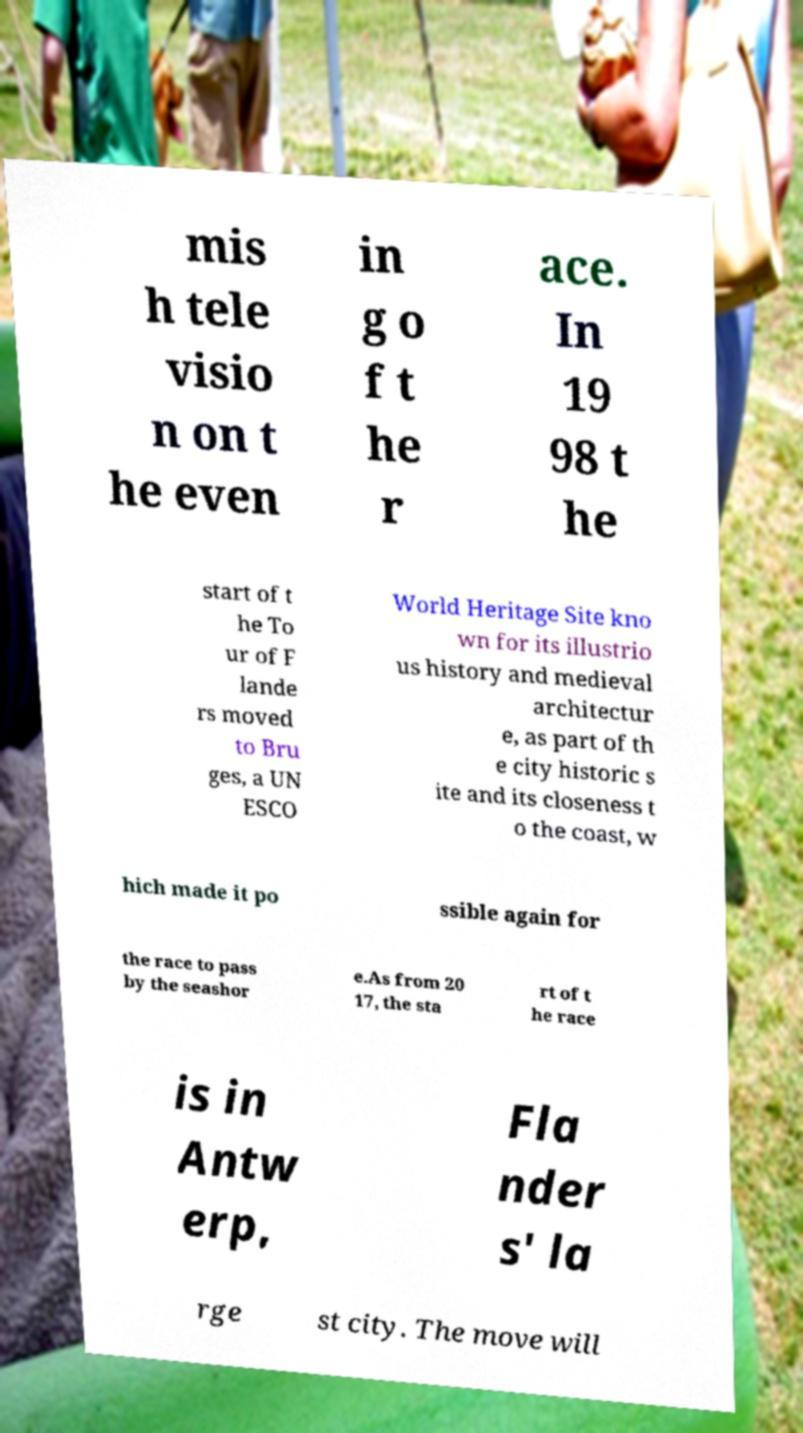Could you extract and type out the text from this image? mis h tele visio n on t he even in g o f t he r ace. In 19 98 t he start of t he To ur of F lande rs moved to Bru ges, a UN ESCO World Heritage Site kno wn for its illustrio us history and medieval architectur e, as part of th e city historic s ite and its closeness t o the coast, w hich made it po ssible again for the race to pass by the seashor e.As from 20 17, the sta rt of t he race is in Antw erp, Fla nder s' la rge st city. The move will 